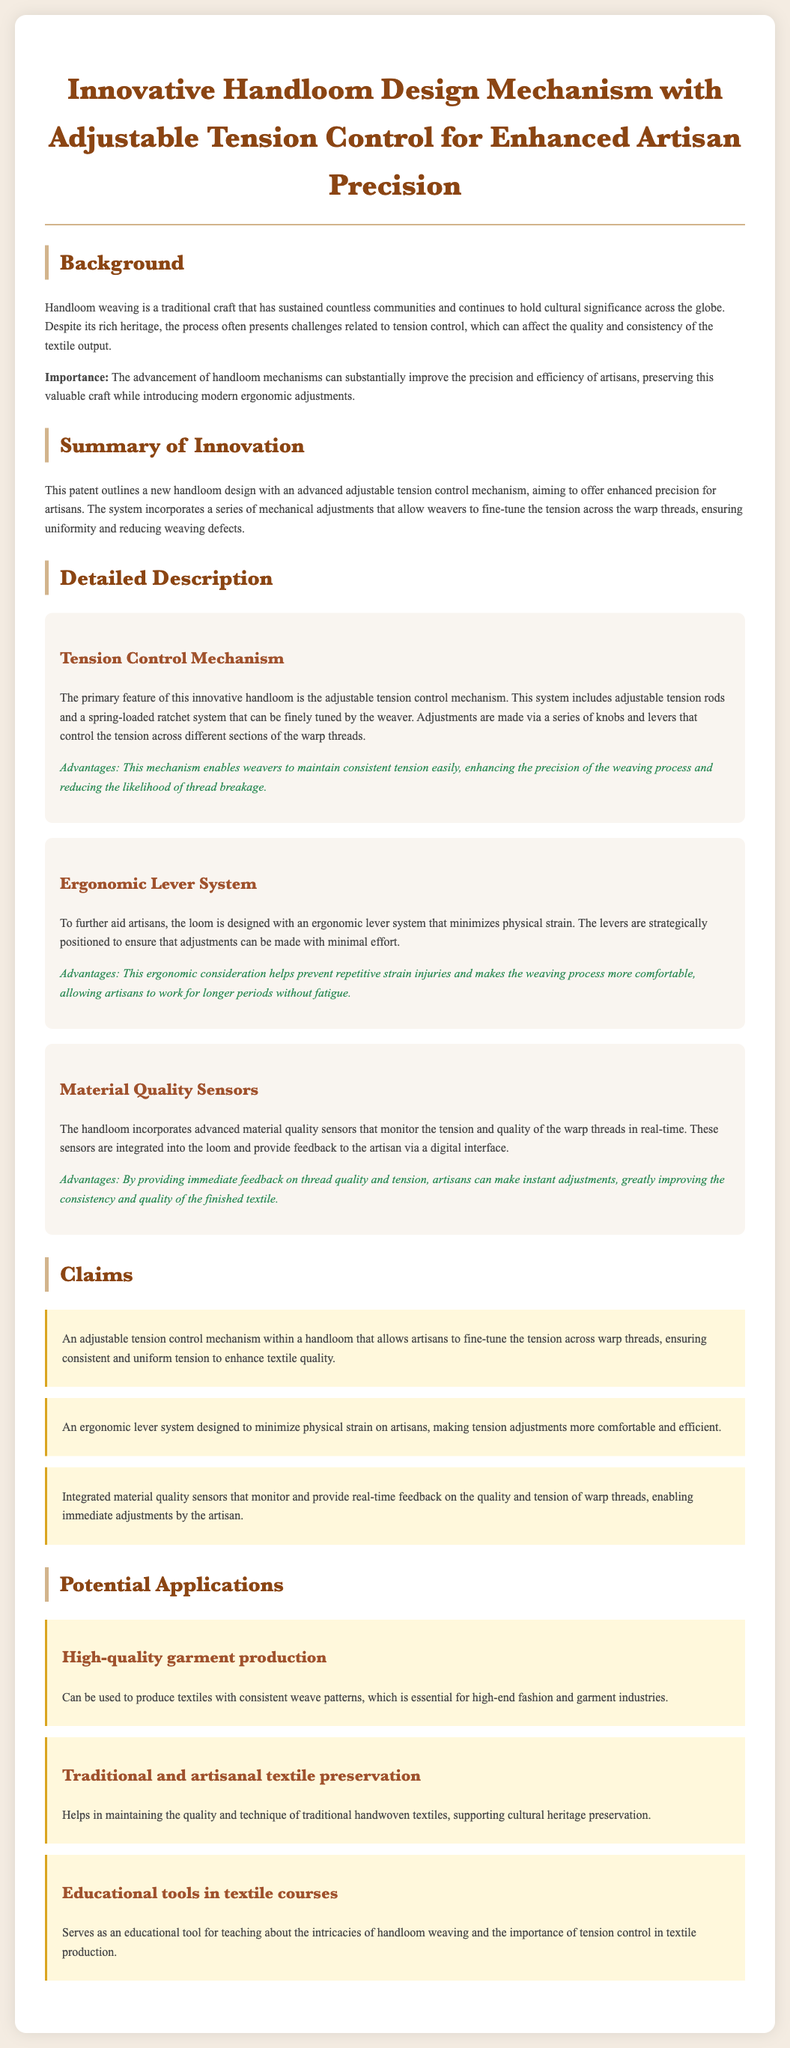what is the title of the patent application? The title is prominently stated at the top of the document, summarizing the innovative aspect of the design.
Answer: Innovative Handloom Design Mechanism with Adjustable Tension Control for Enhanced Artisan Precision what is the main feature of the innovative handloom? The section on the tension control mechanism outlines the primary feature of the handloom.
Answer: Adjustable tension control mechanism how does the ergonomic lever system benefit artisans? The description in the ergonomic lever system component details the benefits provided to artisans.
Answer: Minimizes physical strain what do the material quality sensors monitor? The document states that these sensors are responsible for monitoring certain aspects related to the threads.
Answer: Tension and quality of the warp threads how many claims are listed in the patent? The claims section enumerates the claims made in the patent application.
Answer: Three claims what is one potential application of the innovative handloom? The potential applications section outlines different contexts where the handloom can be utilized.
Answer: High-quality garment production what is the importance of the advancement of handloom mechanisms? The background section underlines the significance of these advancements for artisans.
Answer: Improve precision and efficiency why is the adjustment of tension important in handloom weaving? The background section explains challenges related to tension and its impacts on textile quality.
Answer: Affects quality and consistency of the textile output 